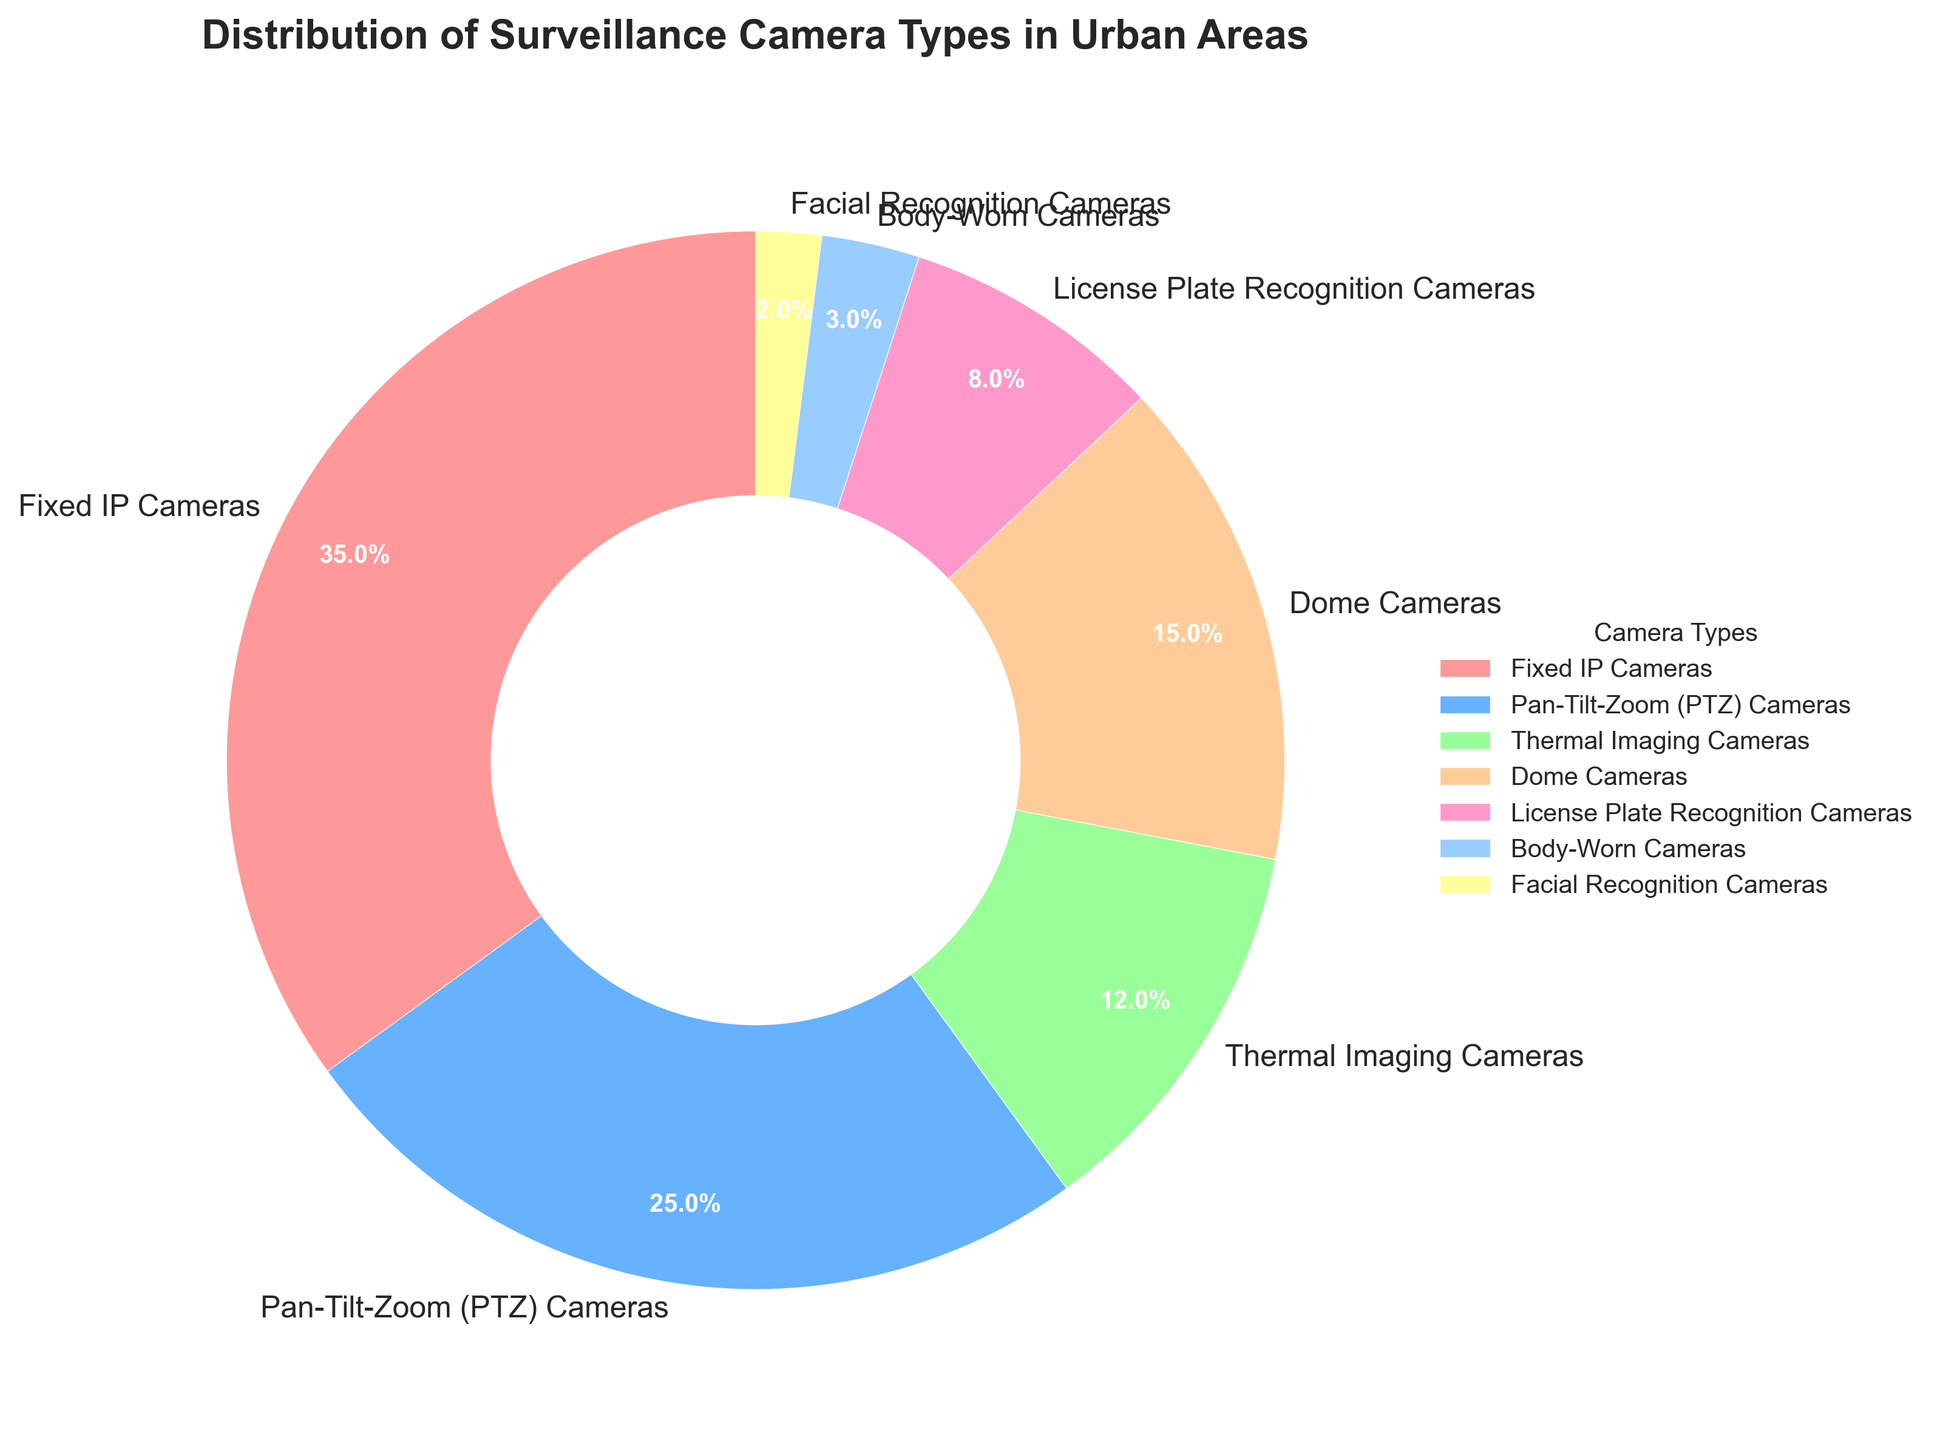What's the most common type of surveillance camera in urban areas? The most common type can be determined by checking the segment with the largest percentage. This is the "Fixed IP Cameras" with 35%.
Answer: Fixed IP Cameras What is the combined percentage of Dome Cameras and Body-Worn Cameras? To find the combined percentage, simply add the individual percentages of Dome Cameras (15%) and Body-Worn Cameras (3%). So, 15% + 3% = 18%.
Answer: 18% Are Thermal Imaging Cameras used more frequently than License Plate Recognition Cameras? Compare the percentages for Thermal Imaging Cameras (12%) and License Plate Recognition Cameras (8%). Since 12% > 8%, Thermal Imaging Cameras are used more frequently.
Answer: Yes Which camera type occupies the smallest portion of the pie chart? The smallest segment can be determined by looking at the camera type with the smallest percentage, which is "Facial Recognition Cameras" with 2%.
Answer: Facial Recognition Cameras How much more popular are Pan-Tilt-Zoom (PTZ) Cameras compared to Facial Recognition Cameras? Subtract the percentage of Facial Recognition Cameras (2%) from the percentage of Pan-Tilt-Zoom (PTZ) Cameras (25%). So, 25% - 2% = 23%.
Answer: 23% What is the total percentage of the three least common camera types? Add the percentages of Body-Worn Cameras (3%), Facial Recognition Cameras (2%), and License Plate Recognition Cameras (8%). So, 3% + 2% + 8% = 13%.
Answer: 13% Which camera type uses the orange color in the visualization? The visual attribute for orange corresponds to the percentage and camera type it represents, which is "Dome Cameras".
Answer: Dome Cameras Is the total percentage of Fixed IP Cameras and Pan-Tilt-Zoom (PTZ) Cameras more than 50%? Add the percentages of Fixed IP Cameras (35%) and Pan-Tilt-Zoom (PTZ) Cameras (25%). So, 35% + 25% = 60%, which is more than 50%.
Answer: Yes, 60% What is the visual attribute of Body-Worn Cameras in the pie chart? Body-Worn Cameras are represented by a segment with the yellow color (confirm by checking the labeled portion of the chart).
Answer: Yellow What percentage of urban surveillance cameras do the more advanced types (Thermal Imaging, License Plate Recognition, and Facial Recognition cameras) comprise together? Add the percentages for Thermal Imaging Cameras (12%), License Plate Recognition Cameras (8%), and Facial Recognition Cameras (2%). So, 12% + 8% + 2% = 22%.
Answer: 22% 